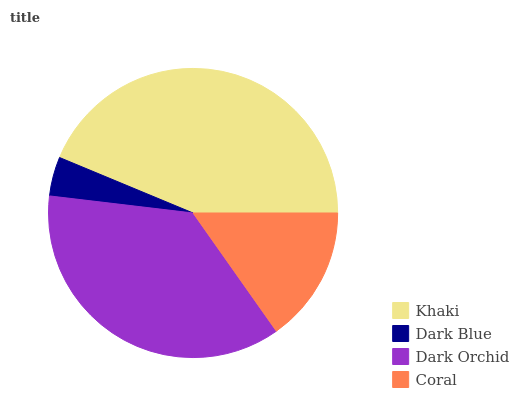Is Dark Blue the minimum?
Answer yes or no. Yes. Is Khaki the maximum?
Answer yes or no. Yes. Is Dark Orchid the minimum?
Answer yes or no. No. Is Dark Orchid the maximum?
Answer yes or no. No. Is Dark Orchid greater than Dark Blue?
Answer yes or no. Yes. Is Dark Blue less than Dark Orchid?
Answer yes or no. Yes. Is Dark Blue greater than Dark Orchid?
Answer yes or no. No. Is Dark Orchid less than Dark Blue?
Answer yes or no. No. Is Dark Orchid the high median?
Answer yes or no. Yes. Is Coral the low median?
Answer yes or no. Yes. Is Khaki the high median?
Answer yes or no. No. Is Dark Orchid the low median?
Answer yes or no. No. 